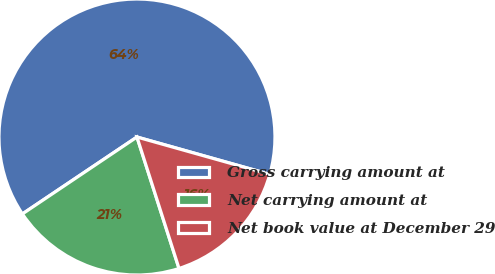Convert chart. <chart><loc_0><loc_0><loc_500><loc_500><pie_chart><fcel>Gross carrying amount at<fcel>Net carrying amount at<fcel>Net book value at December 29<nl><fcel>63.77%<fcel>20.52%<fcel>15.71%<nl></chart> 